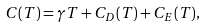Convert formula to latex. <formula><loc_0><loc_0><loc_500><loc_500>C ( T ) = \gamma T + C _ { D } ( T ) + C _ { E } ( T ) ,</formula> 